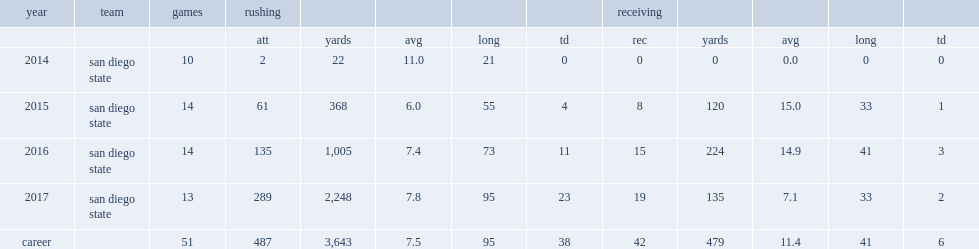How many rec did rashaad penny score in 2017? 19.0. 